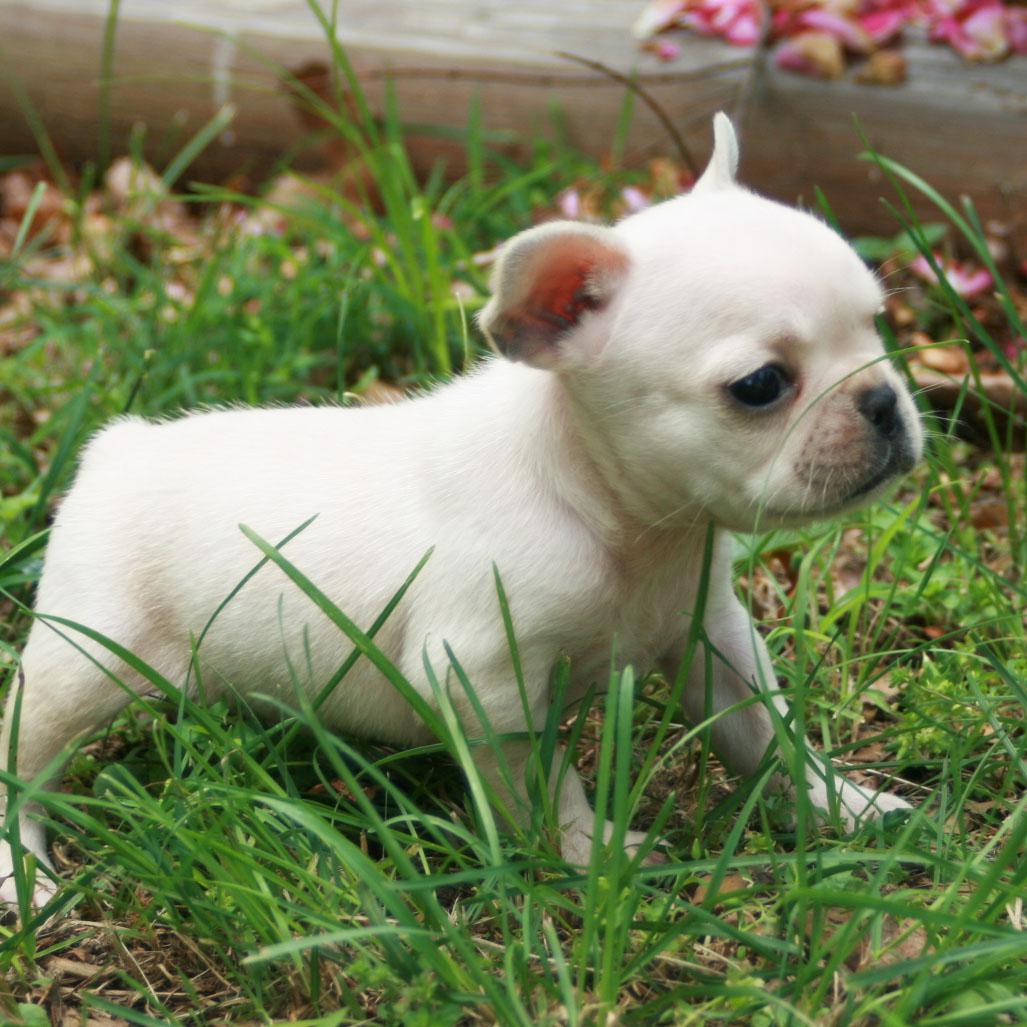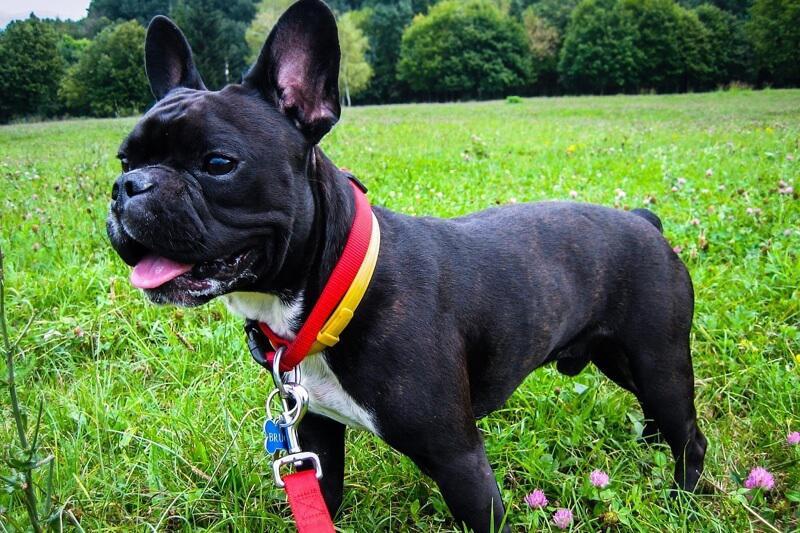The first image is the image on the left, the second image is the image on the right. For the images displayed, is the sentence "There are two dogs in the right image." factually correct? Answer yes or no. No. The first image is the image on the left, the second image is the image on the right. Examine the images to the left and right. Is the description "One of the images shows a bulldog on a leash with its body facing leftward." accurate? Answer yes or no. Yes. 